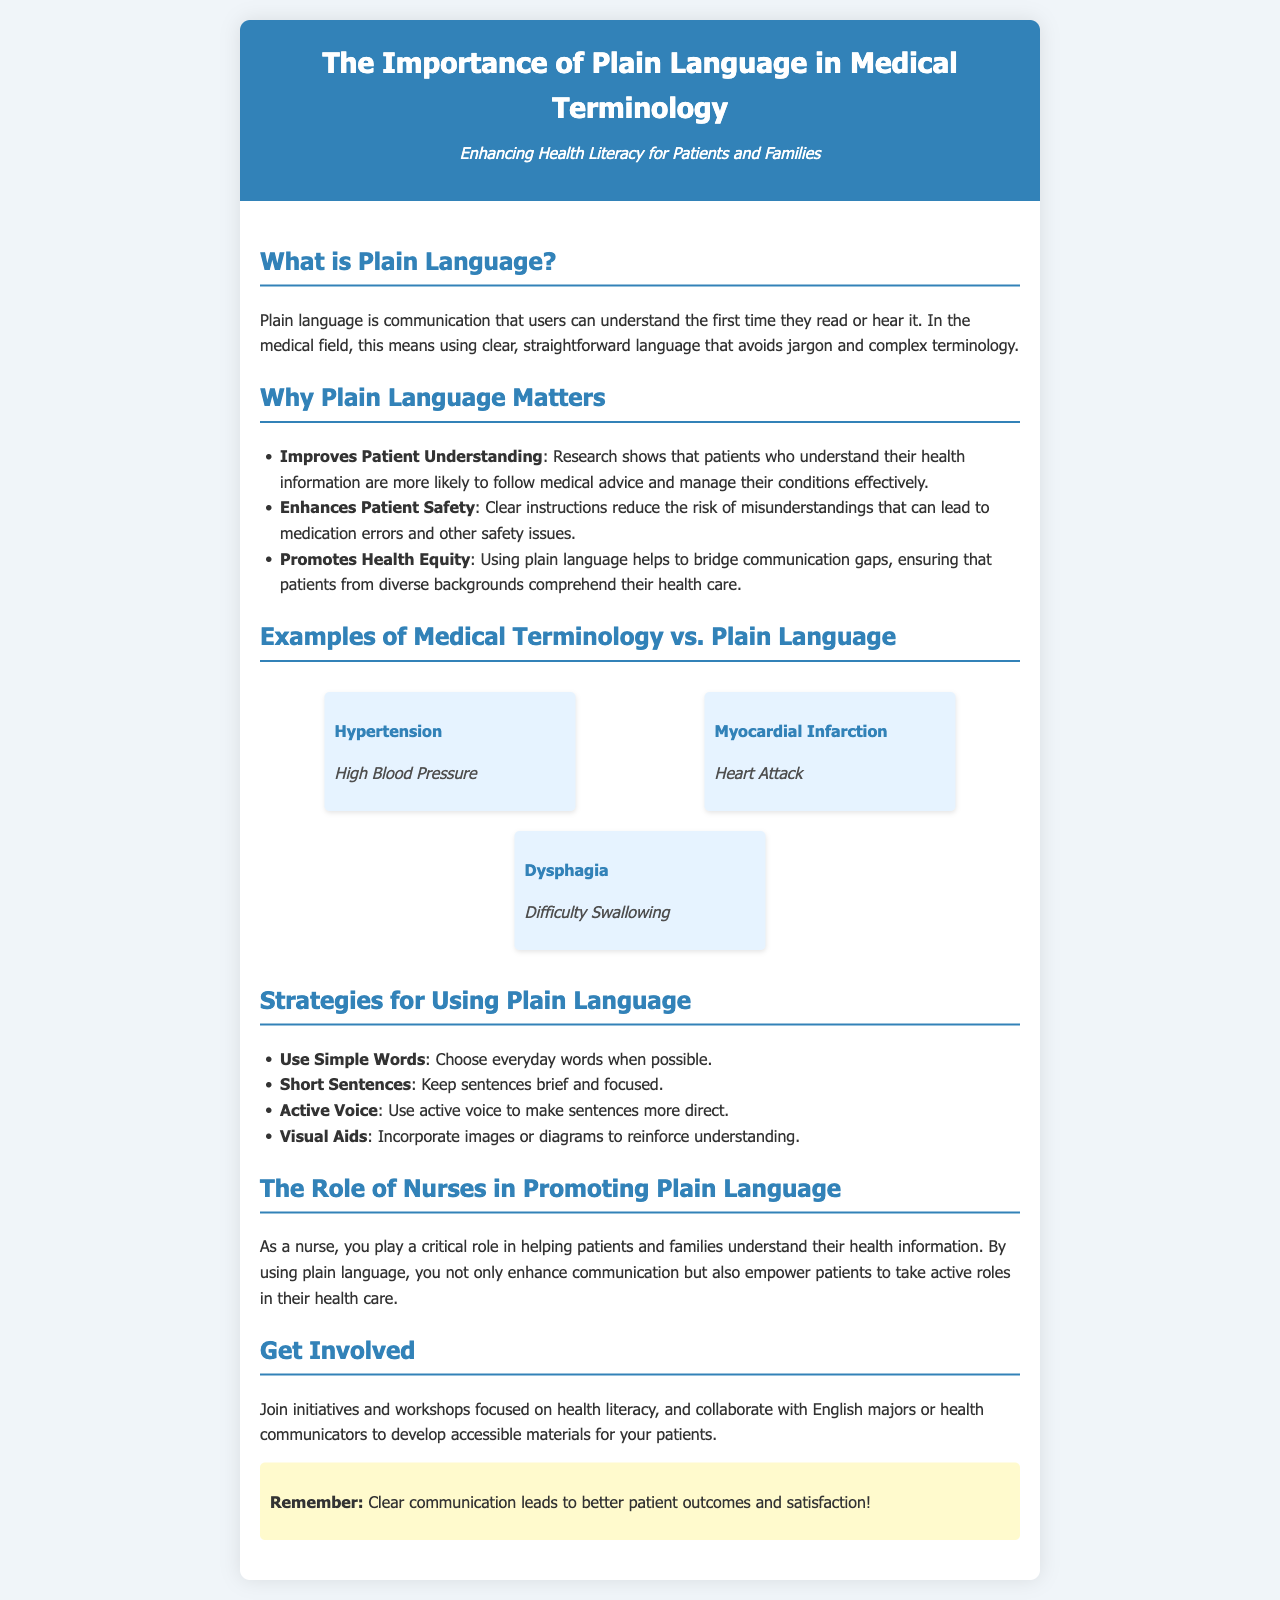What is plain language? Plain language is communication that users can understand the first time they read or hear it.
Answer: Communication that users can understand the first time Why does plain language matter? The brochure lists several reasons why plain language is important, including improving patient understanding and safety.
Answer: Improves Patient Understanding What is a common medical term for 'hypertension'? The document provides an example comparing medical terminology and plain language.
Answer: High Blood Pressure What role do nurses play in promoting plain language? The brochure states that nurses enhance communication and empower patients by using plain language.
Answer: Critical role in helping patients understand What is one strategy for using plain language? The brochure lists specific strategies that individuals can use to ensure clear communication.
Answer: Use Simple Words What does the subtitle of the brochure emphasize? The subtitle highlights the overall theme and purpose of the brochure regarding health literacy.
Answer: Enhancing Health Literacy for Patients and Families How many examples of medical terminology versus plain language are provided? The document showcases a specific number of examples in a defined section.
Answer: Three examples What should you remember about communication according to the brochure? The brochure concludes with an important reminder regarding the outcome of clear communication.
Answer: Clear communication leads to better patient outcomes and satisfaction! Which color is used in the header of the brochure? The document provides a description of the header's visual design elements.
Answer: #3282b8 